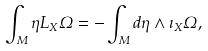Convert formula to latex. <formula><loc_0><loc_0><loc_500><loc_500>\int _ { M } \eta L _ { X } \Omega = - \int _ { M } d \eta \wedge \imath _ { X } \Omega ,</formula> 